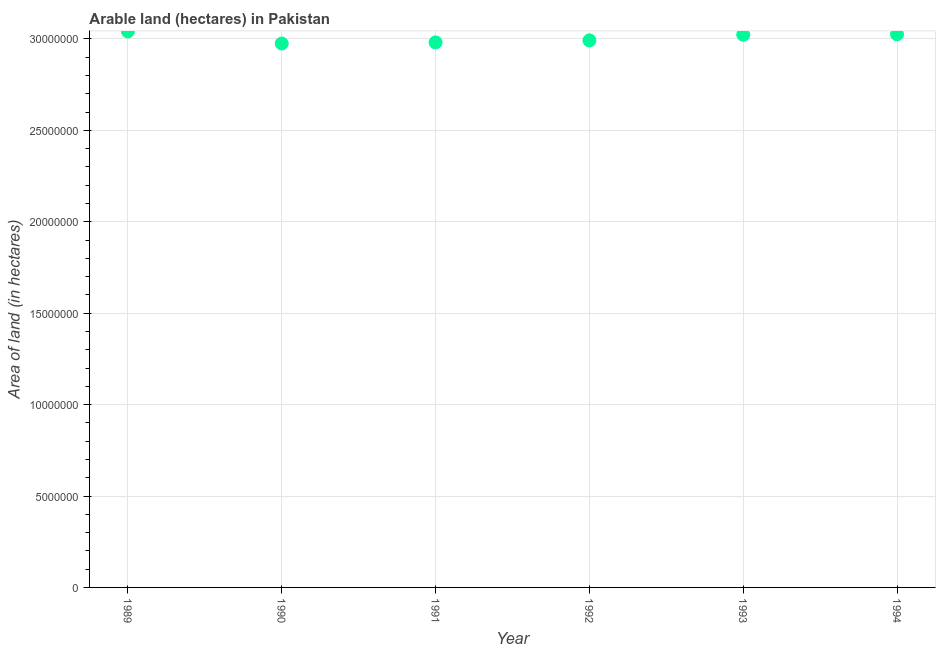What is the area of land in 1992?
Keep it short and to the point. 2.99e+07. Across all years, what is the maximum area of land?
Your response must be concise. 3.04e+07. Across all years, what is the minimum area of land?
Provide a short and direct response. 2.98e+07. In which year was the area of land maximum?
Offer a terse response. 1989. In which year was the area of land minimum?
Give a very brief answer. 1990. What is the sum of the area of land?
Your answer should be very brief. 1.80e+08. What is the difference between the area of land in 1991 and 1992?
Offer a very short reply. -1.10e+05. What is the average area of land per year?
Make the answer very short. 3.01e+07. What is the median area of land?
Offer a terse response. 3.01e+07. In how many years, is the area of land greater than 13000000 hectares?
Ensure brevity in your answer.  6. What is the ratio of the area of land in 1992 to that in 1994?
Ensure brevity in your answer.  0.99. Is the difference between the area of land in 1992 and 1994 greater than the difference between any two years?
Provide a short and direct response. No. What is the difference between the highest and the second highest area of land?
Offer a very short reply. 1.60e+05. Is the sum of the area of land in 1989 and 1993 greater than the maximum area of land across all years?
Offer a terse response. Yes. What is the difference between the highest and the lowest area of land?
Your answer should be compact. 6.60e+05. In how many years, is the area of land greater than the average area of land taken over all years?
Your answer should be compact. 3. Does the area of land monotonically increase over the years?
Give a very brief answer. No. How many dotlines are there?
Your answer should be very brief. 1. What is the difference between two consecutive major ticks on the Y-axis?
Offer a very short reply. 5.00e+06. Are the values on the major ticks of Y-axis written in scientific E-notation?
Offer a very short reply. No. Does the graph contain any zero values?
Your response must be concise. No. What is the title of the graph?
Offer a very short reply. Arable land (hectares) in Pakistan. What is the label or title of the Y-axis?
Your answer should be compact. Area of land (in hectares). What is the Area of land (in hectares) in 1989?
Ensure brevity in your answer.  3.04e+07. What is the Area of land (in hectares) in 1990?
Provide a succinct answer. 2.98e+07. What is the Area of land (in hectares) in 1991?
Offer a terse response. 2.98e+07. What is the Area of land (in hectares) in 1992?
Keep it short and to the point. 2.99e+07. What is the Area of land (in hectares) in 1993?
Provide a short and direct response. 3.02e+07. What is the Area of land (in hectares) in 1994?
Give a very brief answer. 3.02e+07. What is the difference between the Area of land (in hectares) in 1989 and 1992?
Make the answer very short. 4.90e+05. What is the difference between the Area of land (in hectares) in 1989 and 1993?
Offer a terse response. 1.80e+05. What is the difference between the Area of land (in hectares) in 1989 and 1994?
Your answer should be very brief. 1.60e+05. What is the difference between the Area of land (in hectares) in 1990 and 1991?
Your answer should be very brief. -6.00e+04. What is the difference between the Area of land (in hectares) in 1990 and 1992?
Provide a succinct answer. -1.70e+05. What is the difference between the Area of land (in hectares) in 1990 and 1993?
Your answer should be very brief. -4.80e+05. What is the difference between the Area of land (in hectares) in 1990 and 1994?
Your response must be concise. -5.00e+05. What is the difference between the Area of land (in hectares) in 1991 and 1993?
Provide a short and direct response. -4.20e+05. What is the difference between the Area of land (in hectares) in 1991 and 1994?
Provide a short and direct response. -4.40e+05. What is the difference between the Area of land (in hectares) in 1992 and 1993?
Give a very brief answer. -3.10e+05. What is the difference between the Area of land (in hectares) in 1992 and 1994?
Ensure brevity in your answer.  -3.30e+05. What is the ratio of the Area of land (in hectares) in 1989 to that in 1990?
Offer a terse response. 1.02. What is the ratio of the Area of land (in hectares) in 1989 to that in 1991?
Provide a short and direct response. 1.02. What is the ratio of the Area of land (in hectares) in 1989 to that in 1992?
Ensure brevity in your answer.  1.02. What is the ratio of the Area of land (in hectares) in 1989 to that in 1994?
Offer a very short reply. 1. What is the ratio of the Area of land (in hectares) in 1990 to that in 1991?
Ensure brevity in your answer.  1. What is the ratio of the Area of land (in hectares) in 1990 to that in 1993?
Ensure brevity in your answer.  0.98. What is the ratio of the Area of land (in hectares) in 1990 to that in 1994?
Provide a short and direct response. 0.98. What is the ratio of the Area of land (in hectares) in 1993 to that in 1994?
Make the answer very short. 1. 